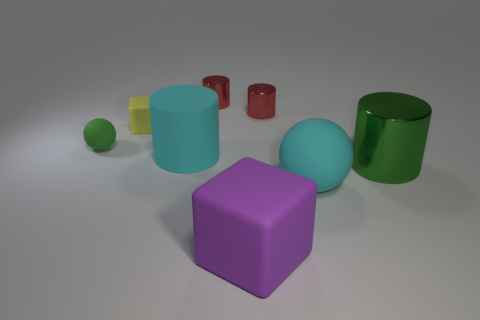Subtract 2 cylinders. How many cylinders are left? 2 Add 2 gray cubes. How many objects exist? 10 Subtract all big cyan matte things. Subtract all blue matte blocks. How many objects are left? 6 Add 6 small green rubber spheres. How many small green rubber spheres are left? 7 Add 3 red cylinders. How many red cylinders exist? 5 Subtract 0 red spheres. How many objects are left? 8 Subtract all blocks. How many objects are left? 6 